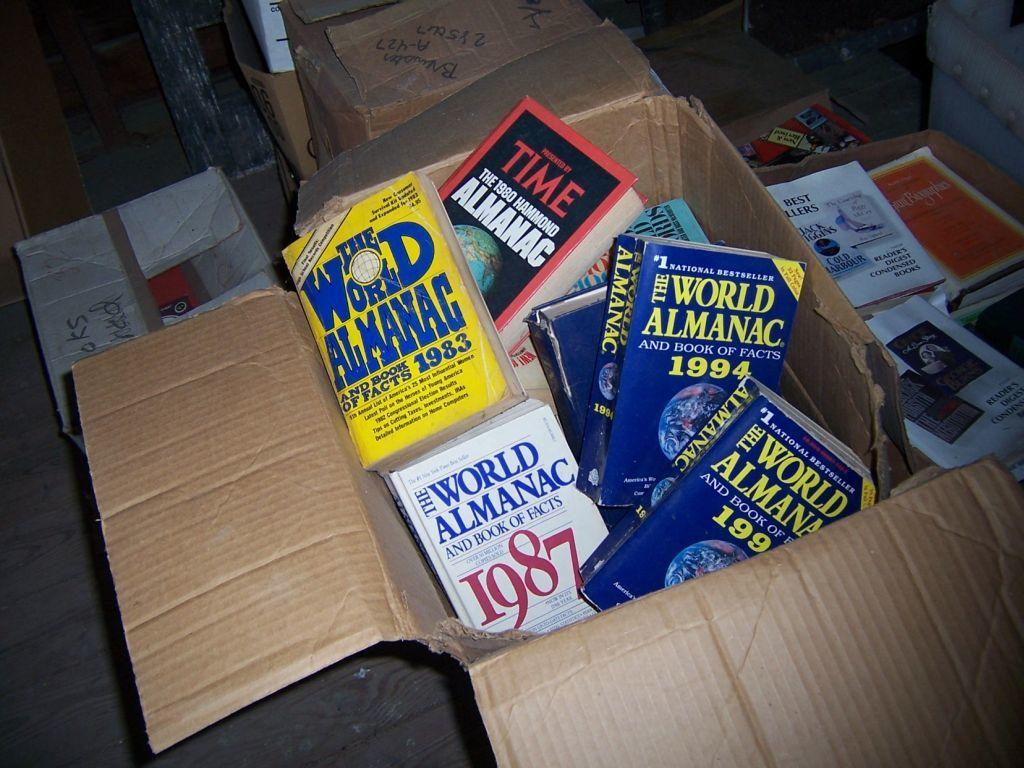<image>
Write a terse but informative summary of the picture. Brown box full of world almanac from years back 